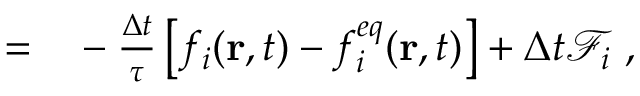<formula> <loc_0><loc_0><loc_500><loc_500>\begin{array} { r l } { = } & - \frac { \Delta t } { \tau } \left [ f _ { i } ( r , t ) - f _ { i } ^ { e q } ( r , t ) \right ] + \Delta { t } \mathcal { F } _ { i } \ , } \end{array}</formula> 